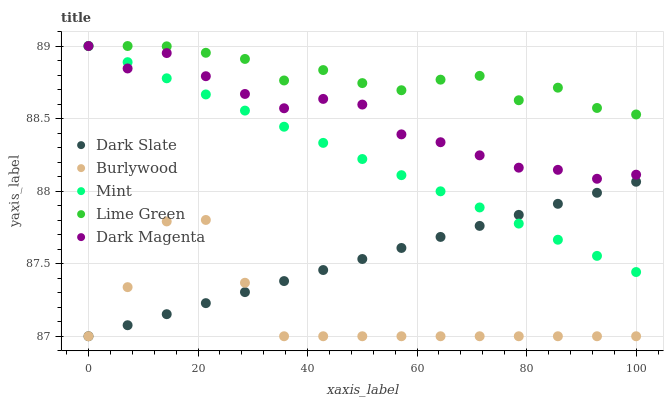Does Burlywood have the minimum area under the curve?
Answer yes or no. Yes. Does Lime Green have the maximum area under the curve?
Answer yes or no. Yes. Does Dark Slate have the minimum area under the curve?
Answer yes or no. No. Does Dark Slate have the maximum area under the curve?
Answer yes or no. No. Is Mint the smoothest?
Answer yes or no. Yes. Is Lime Green the roughest?
Answer yes or no. Yes. Is Dark Slate the smoothest?
Answer yes or no. No. Is Dark Slate the roughest?
Answer yes or no. No. Does Burlywood have the lowest value?
Answer yes or no. Yes. Does Mint have the lowest value?
Answer yes or no. No. Does Lime Green have the highest value?
Answer yes or no. Yes. Does Dark Slate have the highest value?
Answer yes or no. No. Is Burlywood less than Dark Magenta?
Answer yes or no. Yes. Is Lime Green greater than Dark Slate?
Answer yes or no. Yes. Does Mint intersect Dark Magenta?
Answer yes or no. Yes. Is Mint less than Dark Magenta?
Answer yes or no. No. Is Mint greater than Dark Magenta?
Answer yes or no. No. Does Burlywood intersect Dark Magenta?
Answer yes or no. No. 